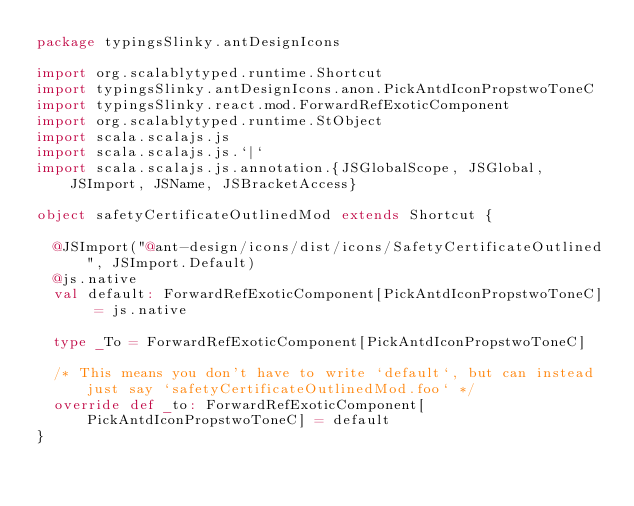Convert code to text. <code><loc_0><loc_0><loc_500><loc_500><_Scala_>package typingsSlinky.antDesignIcons

import org.scalablytyped.runtime.Shortcut
import typingsSlinky.antDesignIcons.anon.PickAntdIconPropstwoToneC
import typingsSlinky.react.mod.ForwardRefExoticComponent
import org.scalablytyped.runtime.StObject
import scala.scalajs.js
import scala.scalajs.js.`|`
import scala.scalajs.js.annotation.{JSGlobalScope, JSGlobal, JSImport, JSName, JSBracketAccess}

object safetyCertificateOutlinedMod extends Shortcut {
  
  @JSImport("@ant-design/icons/dist/icons/SafetyCertificateOutlined", JSImport.Default)
  @js.native
  val default: ForwardRefExoticComponent[PickAntdIconPropstwoToneC] = js.native
  
  type _To = ForwardRefExoticComponent[PickAntdIconPropstwoToneC]
  
  /* This means you don't have to write `default`, but can instead just say `safetyCertificateOutlinedMod.foo` */
  override def _to: ForwardRefExoticComponent[PickAntdIconPropstwoToneC] = default
}
</code> 